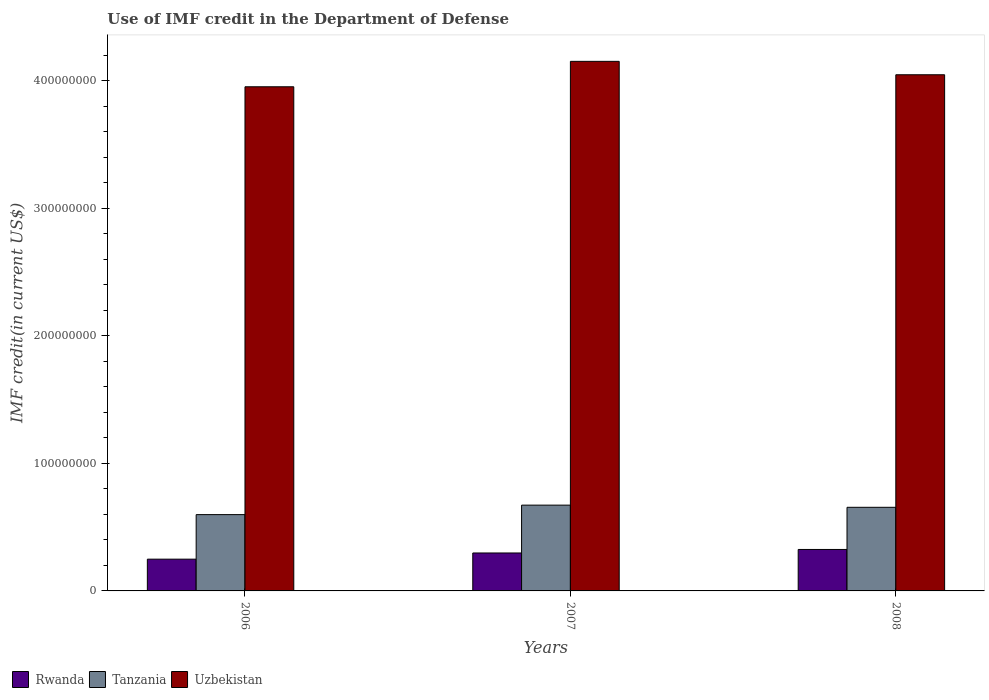What is the IMF credit in the Department of Defense in Uzbekistan in 2006?
Provide a succinct answer. 3.95e+08. Across all years, what is the maximum IMF credit in the Department of Defense in Uzbekistan?
Offer a very short reply. 4.15e+08. Across all years, what is the minimum IMF credit in the Department of Defense in Tanzania?
Ensure brevity in your answer.  5.98e+07. In which year was the IMF credit in the Department of Defense in Uzbekistan minimum?
Offer a terse response. 2006. What is the total IMF credit in the Department of Defense in Uzbekistan in the graph?
Provide a succinct answer. 1.22e+09. What is the difference between the IMF credit in the Department of Defense in Tanzania in 2007 and that in 2008?
Offer a terse response. 1.70e+06. What is the difference between the IMF credit in the Department of Defense in Uzbekistan in 2008 and the IMF credit in the Department of Defense in Tanzania in 2006?
Provide a succinct answer. 3.45e+08. What is the average IMF credit in the Department of Defense in Rwanda per year?
Keep it short and to the point. 2.91e+07. In the year 2006, what is the difference between the IMF credit in the Department of Defense in Tanzania and IMF credit in the Department of Defense in Uzbekistan?
Your response must be concise. -3.36e+08. What is the ratio of the IMF credit in the Department of Defense in Uzbekistan in 2006 to that in 2008?
Offer a terse response. 0.98. Is the IMF credit in the Department of Defense in Uzbekistan in 2007 less than that in 2008?
Your response must be concise. No. What is the difference between the highest and the second highest IMF credit in the Department of Defense in Uzbekistan?
Your answer should be compact. 1.05e+07. What is the difference between the highest and the lowest IMF credit in the Department of Defense in Tanzania?
Offer a very short reply. 7.44e+06. In how many years, is the IMF credit in the Department of Defense in Tanzania greater than the average IMF credit in the Department of Defense in Tanzania taken over all years?
Provide a succinct answer. 2. Is the sum of the IMF credit in the Department of Defense in Rwanda in 2006 and 2008 greater than the maximum IMF credit in the Department of Defense in Uzbekistan across all years?
Offer a very short reply. No. What does the 1st bar from the left in 2007 represents?
Your answer should be compact. Rwanda. What does the 2nd bar from the right in 2006 represents?
Offer a terse response. Tanzania. Is it the case that in every year, the sum of the IMF credit in the Department of Defense in Tanzania and IMF credit in the Department of Defense in Rwanda is greater than the IMF credit in the Department of Defense in Uzbekistan?
Offer a terse response. No. How many bars are there?
Offer a very short reply. 9. Are all the bars in the graph horizontal?
Offer a terse response. No. How many years are there in the graph?
Ensure brevity in your answer.  3. Does the graph contain any zero values?
Make the answer very short. No. Does the graph contain grids?
Ensure brevity in your answer.  No. Where does the legend appear in the graph?
Provide a short and direct response. Bottom left. What is the title of the graph?
Your response must be concise. Use of IMF credit in the Department of Defense. Does "Lebanon" appear as one of the legend labels in the graph?
Keep it short and to the point. No. What is the label or title of the Y-axis?
Keep it short and to the point. IMF credit(in current US$). What is the IMF credit(in current US$) of Rwanda in 2006?
Offer a very short reply. 2.49e+07. What is the IMF credit(in current US$) of Tanzania in 2006?
Your answer should be compact. 5.98e+07. What is the IMF credit(in current US$) in Uzbekistan in 2006?
Your answer should be very brief. 3.95e+08. What is the IMF credit(in current US$) in Rwanda in 2007?
Provide a succinct answer. 2.98e+07. What is the IMF credit(in current US$) in Tanzania in 2007?
Offer a terse response. 6.73e+07. What is the IMF credit(in current US$) of Uzbekistan in 2007?
Offer a very short reply. 4.15e+08. What is the IMF credit(in current US$) in Rwanda in 2008?
Keep it short and to the point. 3.25e+07. What is the IMF credit(in current US$) in Tanzania in 2008?
Give a very brief answer. 6.56e+07. What is the IMF credit(in current US$) in Uzbekistan in 2008?
Provide a short and direct response. 4.05e+08. Across all years, what is the maximum IMF credit(in current US$) in Rwanda?
Your response must be concise. 3.25e+07. Across all years, what is the maximum IMF credit(in current US$) of Tanzania?
Make the answer very short. 6.73e+07. Across all years, what is the maximum IMF credit(in current US$) of Uzbekistan?
Offer a terse response. 4.15e+08. Across all years, what is the minimum IMF credit(in current US$) in Rwanda?
Provide a short and direct response. 2.49e+07. Across all years, what is the minimum IMF credit(in current US$) of Tanzania?
Your answer should be very brief. 5.98e+07. Across all years, what is the minimum IMF credit(in current US$) in Uzbekistan?
Give a very brief answer. 3.95e+08. What is the total IMF credit(in current US$) of Rwanda in the graph?
Keep it short and to the point. 8.72e+07. What is the total IMF credit(in current US$) in Tanzania in the graph?
Your answer should be compact. 1.93e+08. What is the total IMF credit(in current US$) in Uzbekistan in the graph?
Keep it short and to the point. 1.22e+09. What is the difference between the IMF credit(in current US$) in Rwanda in 2006 and that in 2007?
Your answer should be very brief. -4.86e+06. What is the difference between the IMF credit(in current US$) in Tanzania in 2006 and that in 2007?
Offer a terse response. -7.44e+06. What is the difference between the IMF credit(in current US$) of Uzbekistan in 2006 and that in 2007?
Give a very brief answer. -1.99e+07. What is the difference between the IMF credit(in current US$) of Rwanda in 2006 and that in 2008?
Keep it short and to the point. -7.62e+06. What is the difference between the IMF credit(in current US$) of Tanzania in 2006 and that in 2008?
Give a very brief answer. -5.74e+06. What is the difference between the IMF credit(in current US$) of Uzbekistan in 2006 and that in 2008?
Make the answer very short. -9.43e+06. What is the difference between the IMF credit(in current US$) of Rwanda in 2007 and that in 2008?
Provide a short and direct response. -2.76e+06. What is the difference between the IMF credit(in current US$) of Tanzania in 2007 and that in 2008?
Your answer should be very brief. 1.70e+06. What is the difference between the IMF credit(in current US$) in Uzbekistan in 2007 and that in 2008?
Provide a short and direct response. 1.05e+07. What is the difference between the IMF credit(in current US$) in Rwanda in 2006 and the IMF credit(in current US$) in Tanzania in 2007?
Make the answer very short. -4.24e+07. What is the difference between the IMF credit(in current US$) in Rwanda in 2006 and the IMF credit(in current US$) in Uzbekistan in 2007?
Offer a very short reply. -3.90e+08. What is the difference between the IMF credit(in current US$) of Tanzania in 2006 and the IMF credit(in current US$) of Uzbekistan in 2007?
Your response must be concise. -3.55e+08. What is the difference between the IMF credit(in current US$) in Rwanda in 2006 and the IMF credit(in current US$) in Tanzania in 2008?
Offer a very short reply. -4.07e+07. What is the difference between the IMF credit(in current US$) in Rwanda in 2006 and the IMF credit(in current US$) in Uzbekistan in 2008?
Your response must be concise. -3.80e+08. What is the difference between the IMF credit(in current US$) of Tanzania in 2006 and the IMF credit(in current US$) of Uzbekistan in 2008?
Your response must be concise. -3.45e+08. What is the difference between the IMF credit(in current US$) in Rwanda in 2007 and the IMF credit(in current US$) in Tanzania in 2008?
Offer a terse response. -3.58e+07. What is the difference between the IMF credit(in current US$) of Rwanda in 2007 and the IMF credit(in current US$) of Uzbekistan in 2008?
Your response must be concise. -3.75e+08. What is the difference between the IMF credit(in current US$) in Tanzania in 2007 and the IMF credit(in current US$) in Uzbekistan in 2008?
Your response must be concise. -3.37e+08. What is the average IMF credit(in current US$) in Rwanda per year?
Offer a terse response. 2.91e+07. What is the average IMF credit(in current US$) of Tanzania per year?
Ensure brevity in your answer.  6.42e+07. What is the average IMF credit(in current US$) in Uzbekistan per year?
Offer a very short reply. 4.05e+08. In the year 2006, what is the difference between the IMF credit(in current US$) in Rwanda and IMF credit(in current US$) in Tanzania?
Ensure brevity in your answer.  -3.49e+07. In the year 2006, what is the difference between the IMF credit(in current US$) in Rwanda and IMF credit(in current US$) in Uzbekistan?
Give a very brief answer. -3.70e+08. In the year 2006, what is the difference between the IMF credit(in current US$) in Tanzania and IMF credit(in current US$) in Uzbekistan?
Give a very brief answer. -3.36e+08. In the year 2007, what is the difference between the IMF credit(in current US$) of Rwanda and IMF credit(in current US$) of Tanzania?
Give a very brief answer. -3.75e+07. In the year 2007, what is the difference between the IMF credit(in current US$) of Rwanda and IMF credit(in current US$) of Uzbekistan?
Provide a short and direct response. -3.86e+08. In the year 2007, what is the difference between the IMF credit(in current US$) of Tanzania and IMF credit(in current US$) of Uzbekistan?
Your response must be concise. -3.48e+08. In the year 2008, what is the difference between the IMF credit(in current US$) in Rwanda and IMF credit(in current US$) in Tanzania?
Ensure brevity in your answer.  -3.31e+07. In the year 2008, what is the difference between the IMF credit(in current US$) of Rwanda and IMF credit(in current US$) of Uzbekistan?
Give a very brief answer. -3.72e+08. In the year 2008, what is the difference between the IMF credit(in current US$) in Tanzania and IMF credit(in current US$) in Uzbekistan?
Your response must be concise. -3.39e+08. What is the ratio of the IMF credit(in current US$) in Rwanda in 2006 to that in 2007?
Provide a succinct answer. 0.84. What is the ratio of the IMF credit(in current US$) of Tanzania in 2006 to that in 2007?
Your answer should be very brief. 0.89. What is the ratio of the IMF credit(in current US$) in Rwanda in 2006 to that in 2008?
Your response must be concise. 0.77. What is the ratio of the IMF credit(in current US$) in Tanzania in 2006 to that in 2008?
Offer a terse response. 0.91. What is the ratio of the IMF credit(in current US$) in Uzbekistan in 2006 to that in 2008?
Ensure brevity in your answer.  0.98. What is the ratio of the IMF credit(in current US$) in Rwanda in 2007 to that in 2008?
Make the answer very short. 0.92. What is the ratio of the IMF credit(in current US$) in Uzbekistan in 2007 to that in 2008?
Your answer should be very brief. 1.03. What is the difference between the highest and the second highest IMF credit(in current US$) in Rwanda?
Provide a succinct answer. 2.76e+06. What is the difference between the highest and the second highest IMF credit(in current US$) in Tanzania?
Keep it short and to the point. 1.70e+06. What is the difference between the highest and the second highest IMF credit(in current US$) in Uzbekistan?
Keep it short and to the point. 1.05e+07. What is the difference between the highest and the lowest IMF credit(in current US$) in Rwanda?
Provide a succinct answer. 7.62e+06. What is the difference between the highest and the lowest IMF credit(in current US$) of Tanzania?
Keep it short and to the point. 7.44e+06. What is the difference between the highest and the lowest IMF credit(in current US$) in Uzbekistan?
Your answer should be very brief. 1.99e+07. 